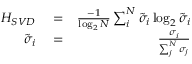Convert formula to latex. <formula><loc_0><loc_0><loc_500><loc_500>\begin{array} { r l r } { H _ { S V D } } & = } & { \frac { - 1 } { \log _ { 2 } N } \sum _ { i } ^ { N } \tilde { \sigma } _ { i } \log _ { 2 } \tilde { \sigma } _ { i } } \\ { \tilde { \sigma } _ { i } } & = } & { \frac { \sigma _ { i } } { \sum _ { j } ^ { N } \sigma _ { j } } } \end{array}</formula> 